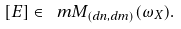Convert formula to latex. <formula><loc_0><loc_0><loc_500><loc_500>[ E ] \in \ m M _ { ( d n , d m ) } ( \omega _ { X } ) .</formula> 